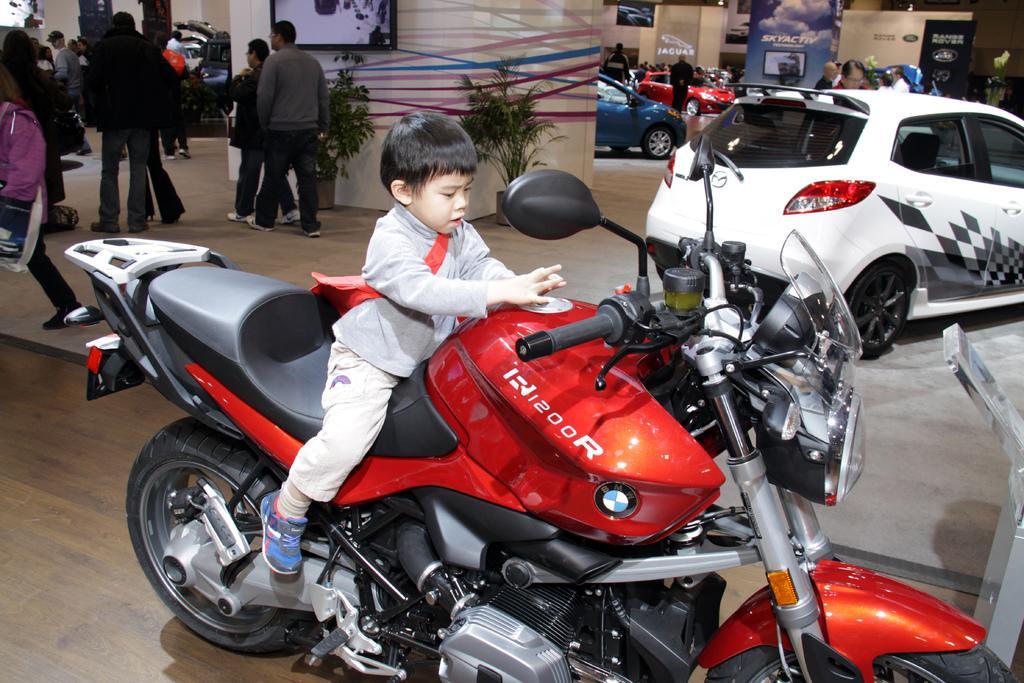In one or two sentences, can you explain what this image depicts? In this we can see a boy sitting on the bike, and at back her is the car travelling on the floor, and at back here a group of people are standing, and here is the television, and here are the trees. 